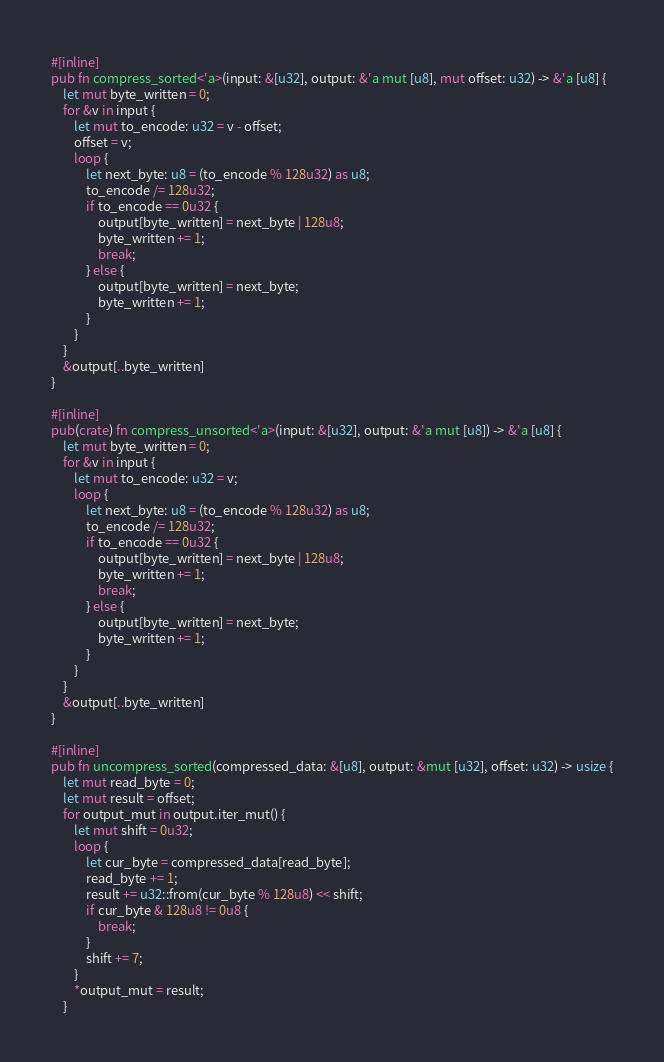Convert code to text. <code><loc_0><loc_0><loc_500><loc_500><_Rust_>#[inline]
pub fn compress_sorted<'a>(input: &[u32], output: &'a mut [u8], mut offset: u32) -> &'a [u8] {
    let mut byte_written = 0;
    for &v in input {
        let mut to_encode: u32 = v - offset;
        offset = v;
        loop {
            let next_byte: u8 = (to_encode % 128u32) as u8;
            to_encode /= 128u32;
            if to_encode == 0u32 {
                output[byte_written] = next_byte | 128u8;
                byte_written += 1;
                break;
            } else {
                output[byte_written] = next_byte;
                byte_written += 1;
            }
        }
    }
    &output[..byte_written]
}

#[inline]
pub(crate) fn compress_unsorted<'a>(input: &[u32], output: &'a mut [u8]) -> &'a [u8] {
    let mut byte_written = 0;
    for &v in input {
        let mut to_encode: u32 = v;
        loop {
            let next_byte: u8 = (to_encode % 128u32) as u8;
            to_encode /= 128u32;
            if to_encode == 0u32 {
                output[byte_written] = next_byte | 128u8;
                byte_written += 1;
                break;
            } else {
                output[byte_written] = next_byte;
                byte_written += 1;
            }
        }
    }
    &output[..byte_written]
}

#[inline]
pub fn uncompress_sorted(compressed_data: &[u8], output: &mut [u32], offset: u32) -> usize {
    let mut read_byte = 0;
    let mut result = offset;
    for output_mut in output.iter_mut() {
        let mut shift = 0u32;
        loop {
            let cur_byte = compressed_data[read_byte];
            read_byte += 1;
            result += u32::from(cur_byte % 128u8) << shift;
            if cur_byte & 128u8 != 0u8 {
                break;
            }
            shift += 7;
        }
        *output_mut = result;
    }</code> 